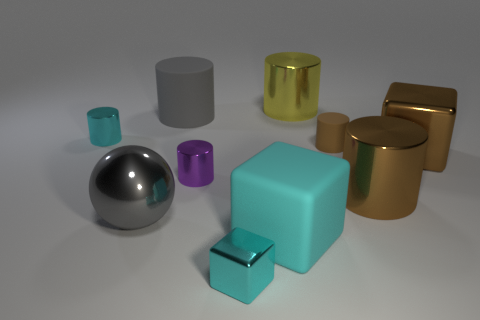What number of other things are the same shape as the purple shiny object?
Make the answer very short. 5. There is a big matte object behind the big matte block; what shape is it?
Make the answer very short. Cylinder. There is a tiny brown object; does it have the same shape as the large shiny thing left of the yellow cylinder?
Offer a terse response. No. There is a shiny thing that is both to the left of the gray cylinder and behind the metallic sphere; what size is it?
Give a very brief answer. Small. There is a big thing that is in front of the big brown metal cylinder and to the right of the gray cylinder; what is its color?
Your answer should be very brief. Cyan. Is there anything else that has the same material as the purple cylinder?
Give a very brief answer. Yes. Are there fewer brown objects that are in front of the large brown metal cube than tiny metal blocks that are behind the large gray sphere?
Your answer should be compact. No. Are there any other things that have the same color as the tiny metal block?
Offer a terse response. Yes. There is a gray rubber thing; what shape is it?
Your answer should be compact. Cylinder. What is the color of the tiny cylinder that is the same material as the large gray cylinder?
Make the answer very short. Brown. 